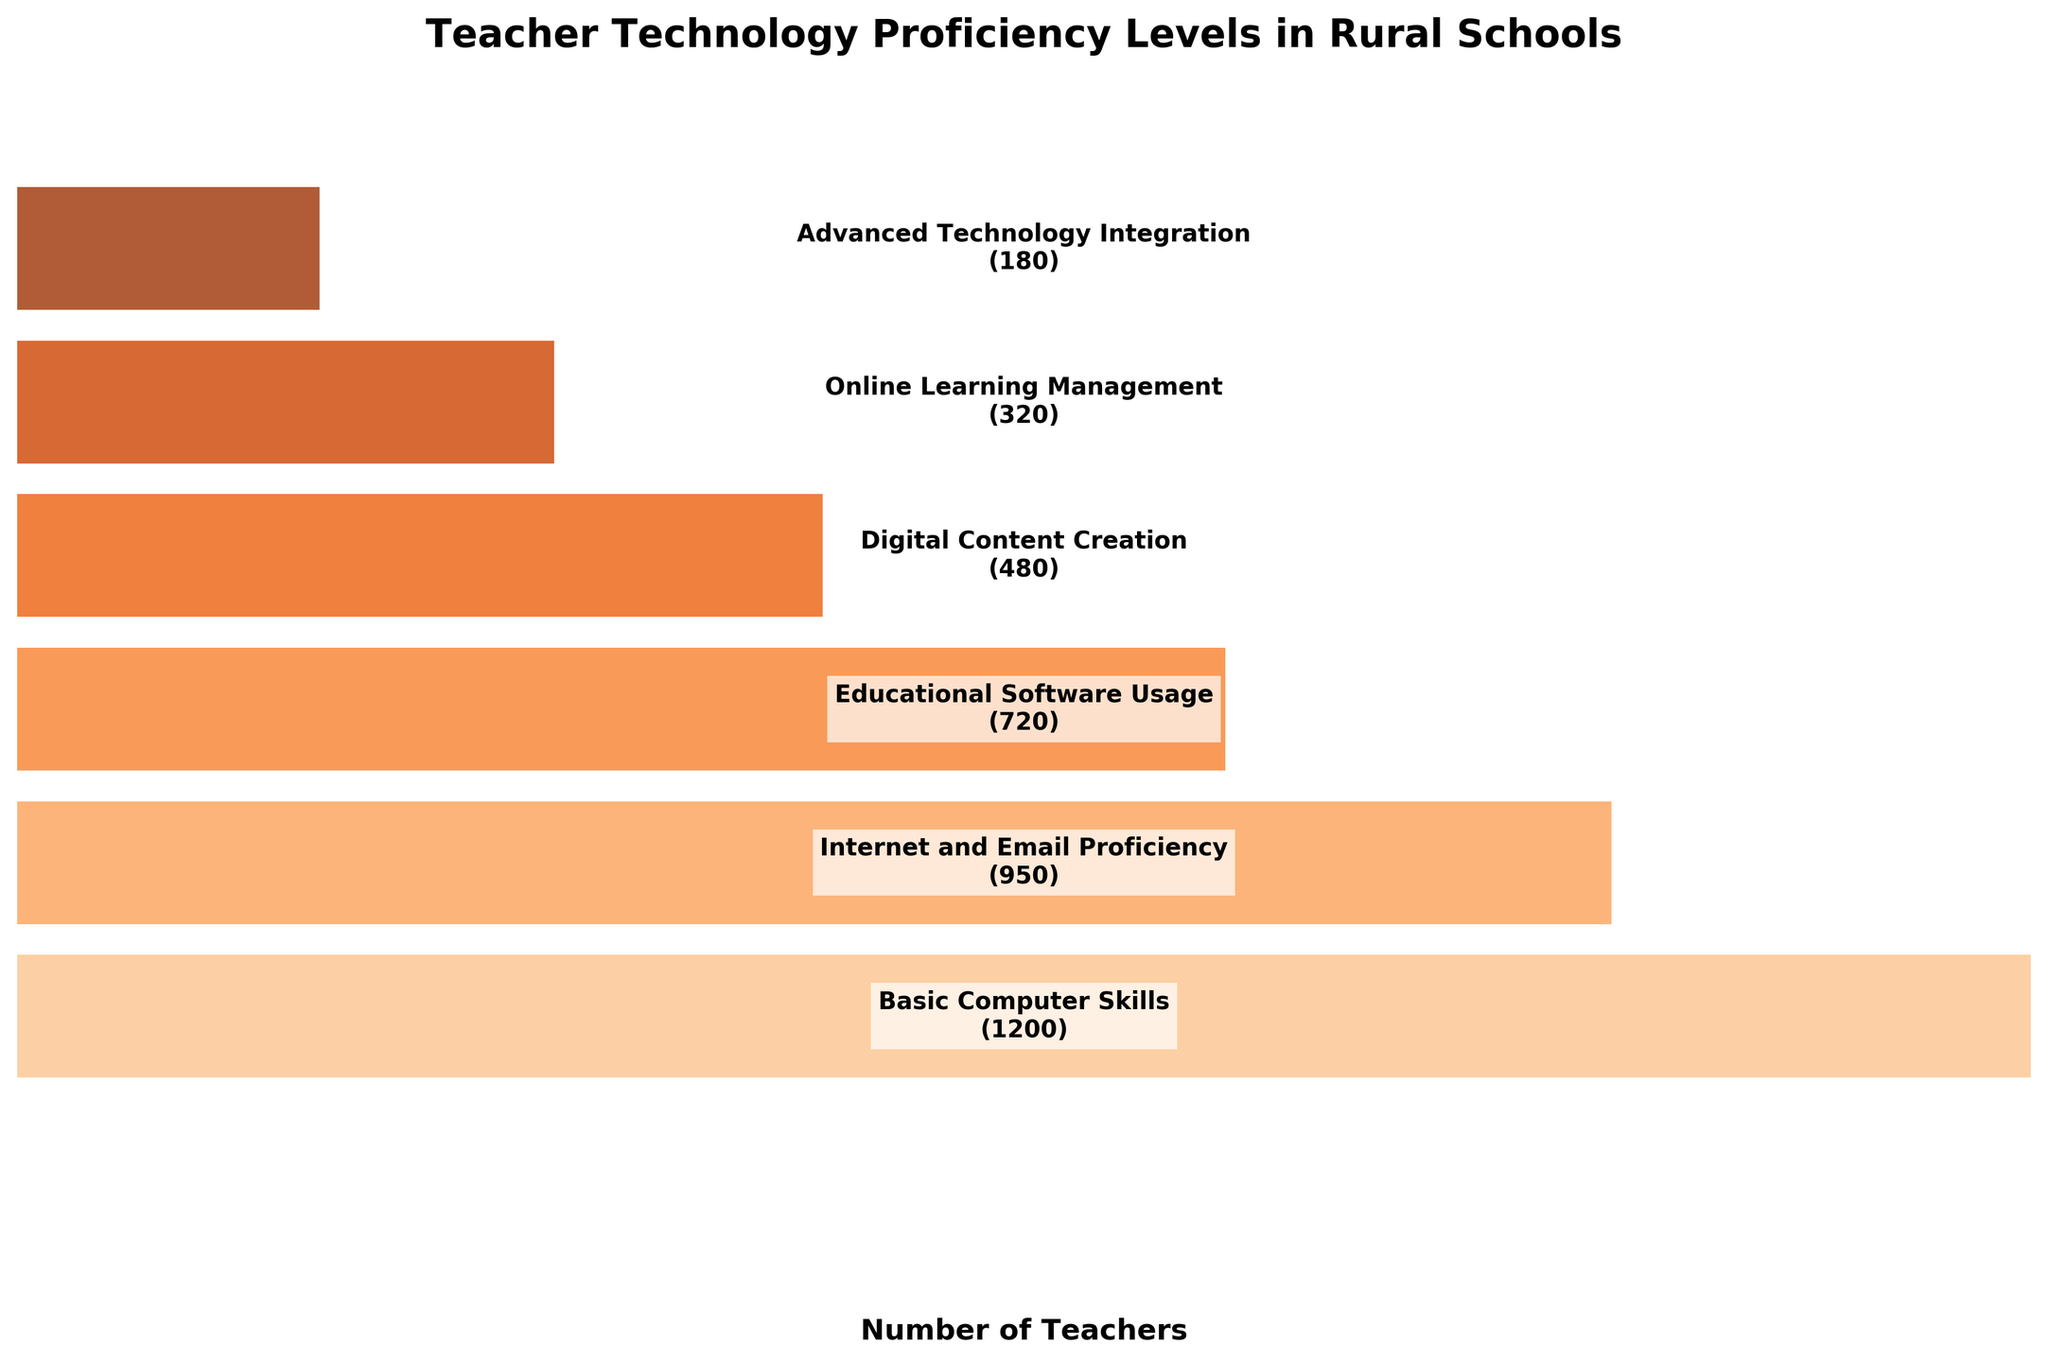What is the title of the figure? The title is usually displayed at the top of the plot to provide context. In this case, it describes the content of the chart.
Answer: "Teacher Technology Proficiency Levels in Rural Schools." How many technology proficiency levels are there in the chart? By counting the unique bars representing different skill levels in the figure, one can determine the number of proficiency levels.
Answer: 6 Which technology skill level has the highest number of teachers? By observing the width of the bars, the widest bar corresponds to the highest number of teachers.
Answer: Basic Computer Skills What is the difference in the number of teachers between those proficient in Basic Computer Skills and those in Advanced Technology Integration? Subtract the number of teachers in Advanced Technology Integration (180) from those in Basic Computer Skills (1200).
Answer: 1020 What is the ratio of teachers proficient in Online Learning Management to those in Educational Software Usage? Divide the number of teachers proficient in Online Learning Management (320) by those in Educational Software Usage (720).
Answer: 0.44 Are more teachers proficient in Digital Content Creation or Internet and Email Proficiency? Compare the widths of the bars for Digital Content Creation (480) and Internet and Email Proficiency (950).
Answer: Internet and Email Proficiency What is the sum of teachers proficient in Educational Software Usage and Digital Content Creation? Add the number of teachers proficient in Educational Software Usage (720) and Digital Content Creation (480).
Answer: 1200 Which skill level has the least number of teachers, and what is that number? Identify the narrowest bar on the chart, which represents the skill level with the fewest teachers.
Answer: Advanced Technology Integration, 180 By how much does the number of teachers proficient in Internet and Email Proficiency exceed those proficient in Online Learning Management? Subtract the number of teachers in Online Learning Management (320) from those in Internet and Email Proficiency (950).
Answer: 630 What pattern can be observed as the proficiency levels progress from Basic Computer Skills to Advanced Technology Integration? Notice the trend in the bar widths, where each subsequent skill level generally has fewer teachers, creating a funnel shape.
Answer: Decreasing number of teachers 